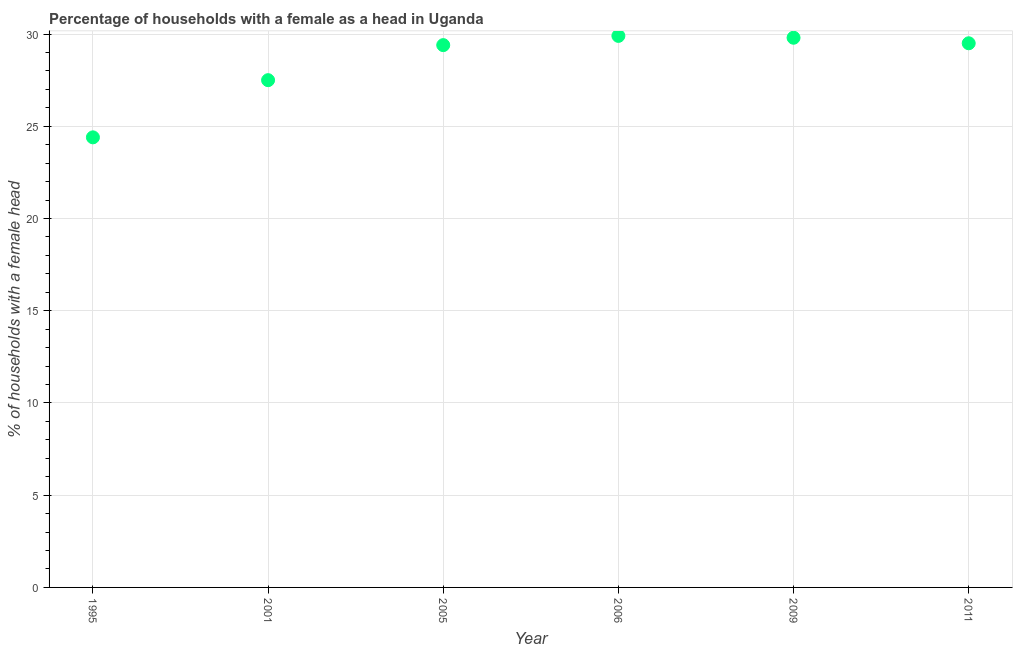What is the number of female supervised households in 1995?
Your answer should be compact. 24.4. Across all years, what is the maximum number of female supervised households?
Your answer should be very brief. 29.9. Across all years, what is the minimum number of female supervised households?
Ensure brevity in your answer.  24.4. In which year was the number of female supervised households maximum?
Provide a short and direct response. 2006. What is the sum of the number of female supervised households?
Offer a terse response. 170.5. What is the difference between the number of female supervised households in 2009 and 2011?
Your answer should be compact. 0.3. What is the average number of female supervised households per year?
Your response must be concise. 28.42. What is the median number of female supervised households?
Your answer should be compact. 29.45. Do a majority of the years between 2009 and 2006 (inclusive) have number of female supervised households greater than 16 %?
Offer a very short reply. No. What is the ratio of the number of female supervised households in 2001 to that in 2009?
Your response must be concise. 0.92. Is the number of female supervised households in 2001 less than that in 2009?
Your response must be concise. Yes. What is the difference between the highest and the second highest number of female supervised households?
Make the answer very short. 0.1. Is the sum of the number of female supervised households in 1995 and 2011 greater than the maximum number of female supervised households across all years?
Provide a succinct answer. Yes. What is the difference between the highest and the lowest number of female supervised households?
Give a very brief answer. 5.5. Does the number of female supervised households monotonically increase over the years?
Provide a short and direct response. No. How many dotlines are there?
Provide a succinct answer. 1. Does the graph contain grids?
Provide a short and direct response. Yes. What is the title of the graph?
Your response must be concise. Percentage of households with a female as a head in Uganda. What is the label or title of the Y-axis?
Your response must be concise. % of households with a female head. What is the % of households with a female head in 1995?
Make the answer very short. 24.4. What is the % of households with a female head in 2001?
Ensure brevity in your answer.  27.5. What is the % of households with a female head in 2005?
Provide a succinct answer. 29.4. What is the % of households with a female head in 2006?
Offer a very short reply. 29.9. What is the % of households with a female head in 2009?
Offer a very short reply. 29.8. What is the % of households with a female head in 2011?
Your answer should be very brief. 29.5. What is the difference between the % of households with a female head in 1995 and 2009?
Make the answer very short. -5.4. What is the difference between the % of households with a female head in 2001 and 2005?
Ensure brevity in your answer.  -1.9. What is the difference between the % of households with a female head in 2001 and 2006?
Your response must be concise. -2.4. What is the difference between the % of households with a female head in 2001 and 2009?
Offer a terse response. -2.3. What is the difference between the % of households with a female head in 2001 and 2011?
Give a very brief answer. -2. What is the difference between the % of households with a female head in 2005 and 2009?
Your answer should be very brief. -0.4. What is the difference between the % of households with a female head in 2005 and 2011?
Provide a succinct answer. -0.1. What is the difference between the % of households with a female head in 2006 and 2009?
Ensure brevity in your answer.  0.1. What is the difference between the % of households with a female head in 2006 and 2011?
Keep it short and to the point. 0.4. What is the difference between the % of households with a female head in 2009 and 2011?
Make the answer very short. 0.3. What is the ratio of the % of households with a female head in 1995 to that in 2001?
Provide a succinct answer. 0.89. What is the ratio of the % of households with a female head in 1995 to that in 2005?
Your answer should be compact. 0.83. What is the ratio of the % of households with a female head in 1995 to that in 2006?
Provide a short and direct response. 0.82. What is the ratio of the % of households with a female head in 1995 to that in 2009?
Your answer should be compact. 0.82. What is the ratio of the % of households with a female head in 1995 to that in 2011?
Provide a short and direct response. 0.83. What is the ratio of the % of households with a female head in 2001 to that in 2005?
Provide a short and direct response. 0.94. What is the ratio of the % of households with a female head in 2001 to that in 2006?
Your answer should be compact. 0.92. What is the ratio of the % of households with a female head in 2001 to that in 2009?
Keep it short and to the point. 0.92. What is the ratio of the % of households with a female head in 2001 to that in 2011?
Your response must be concise. 0.93. What is the ratio of the % of households with a female head in 2005 to that in 2006?
Your answer should be very brief. 0.98. What is the ratio of the % of households with a female head in 2006 to that in 2009?
Your response must be concise. 1. What is the ratio of the % of households with a female head in 2006 to that in 2011?
Ensure brevity in your answer.  1.01. What is the ratio of the % of households with a female head in 2009 to that in 2011?
Provide a succinct answer. 1.01. 